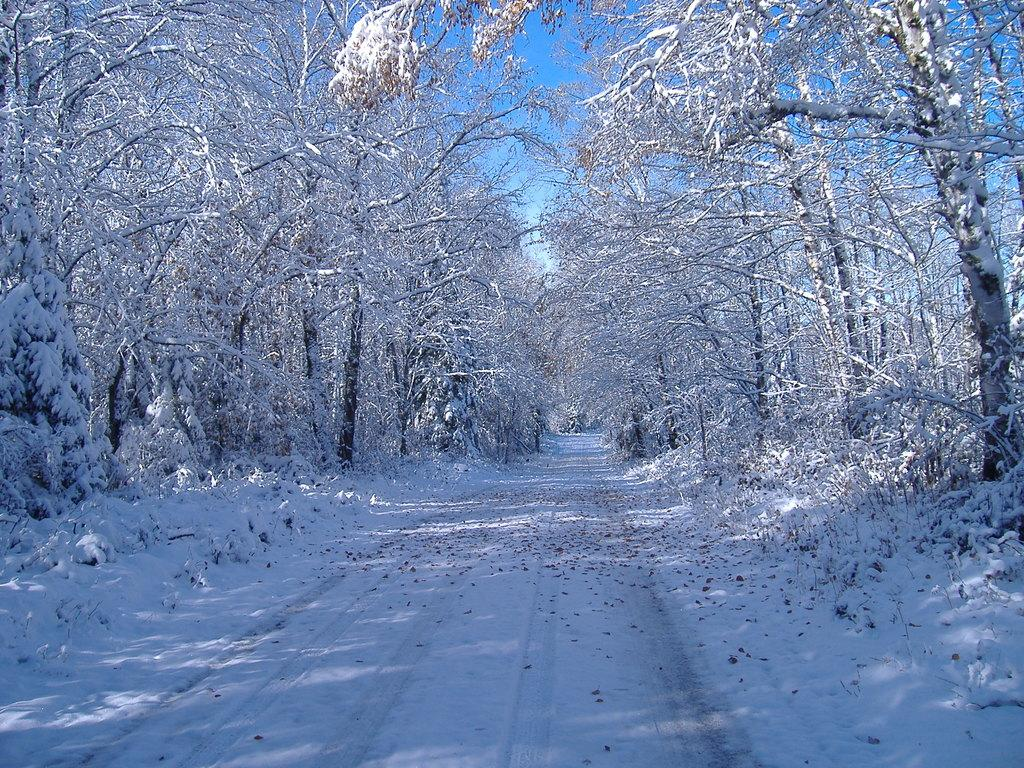What type of vegetation is present in the image? There are many trees in the image. What is located at the bottom of the image? There is a road at the bottom of the image. What can be seen on the trees and ground in the image? Leaves are visible in the image. What is the weather like in the image? Snow is present in the image, indicating a cold or wintry environment. What is visible at the top of the image? There is a sky visible at the top of the image. Where is the key located in the image? There is no key present in the image. What type of desk can be seen in the image? There is no desk present in the image. 